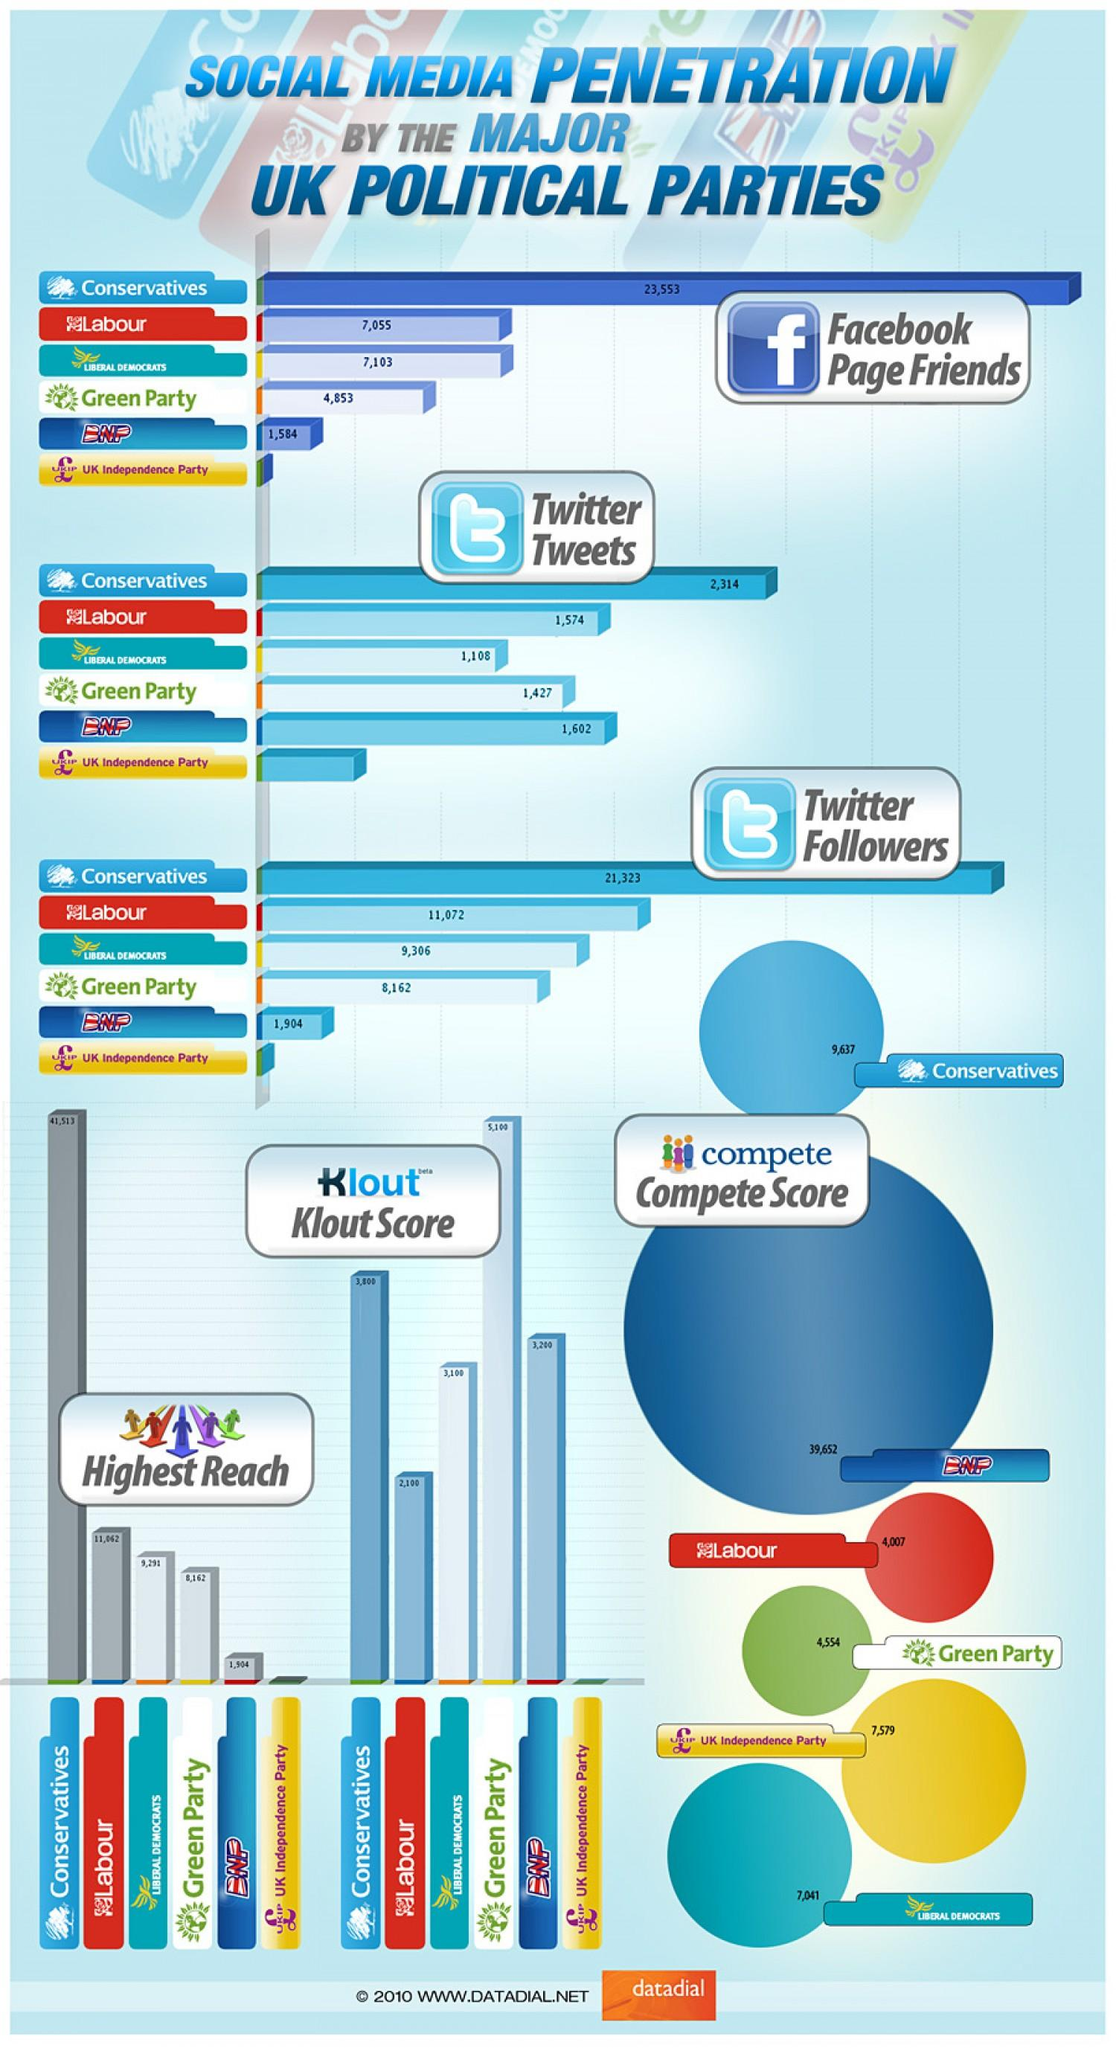Highlight a few significant elements in this photo. The British National Party (BNP) has fewer Twitter tweets than the Conservative Party, which places them just below the Conservatives in terms of social media engagement. The difference between the friends on Facebook and followers on Twitter among Conservatives is 2,230. BNP has more followers/friends on Twitter than on FaceBook. BNP has the second lowest level of Facebook penetration among the countries listed. The Labour party's score is 4007. 